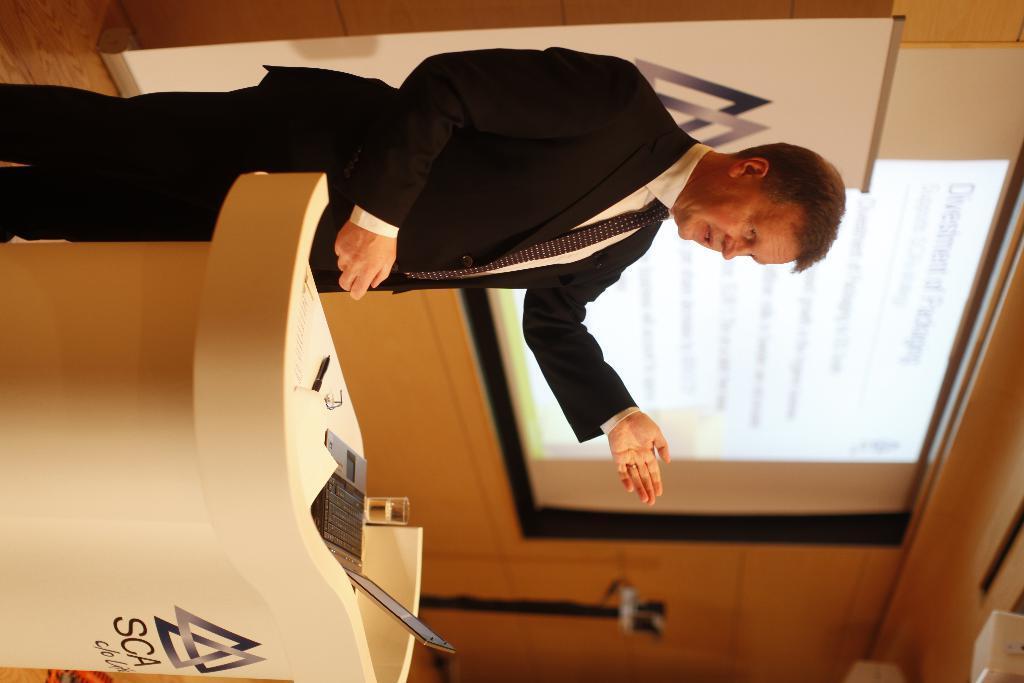Could you give a brief overview of what you see in this image? In this picture I can observe a person standing on the floor in front of a podium. There is a laptop on the podium. In the background I can observe projector display screen and a wall. 